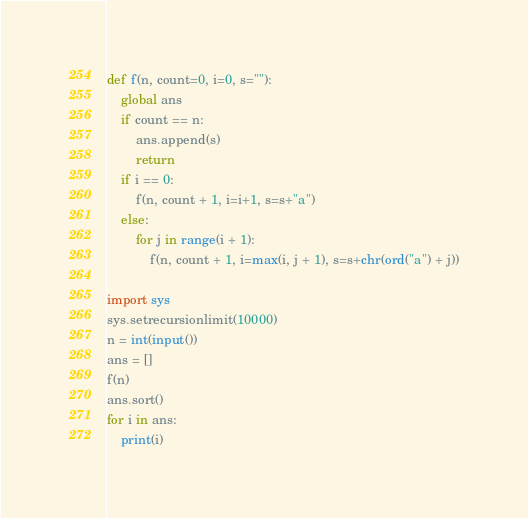Convert code to text. <code><loc_0><loc_0><loc_500><loc_500><_Python_>def f(n, count=0, i=0, s=""):
    global ans
    if count == n:
        ans.append(s)
        return
    if i == 0:
        f(n, count + 1, i=i+1, s=s+"a")
    else:
        for j in range(i + 1):
            f(n, count + 1, i=max(i, j + 1), s=s+chr(ord("a") + j))

import sys
sys.setrecursionlimit(10000)
n = int(input())
ans = []
f(n)
ans.sort()
for i in ans:
    print(i)</code> 